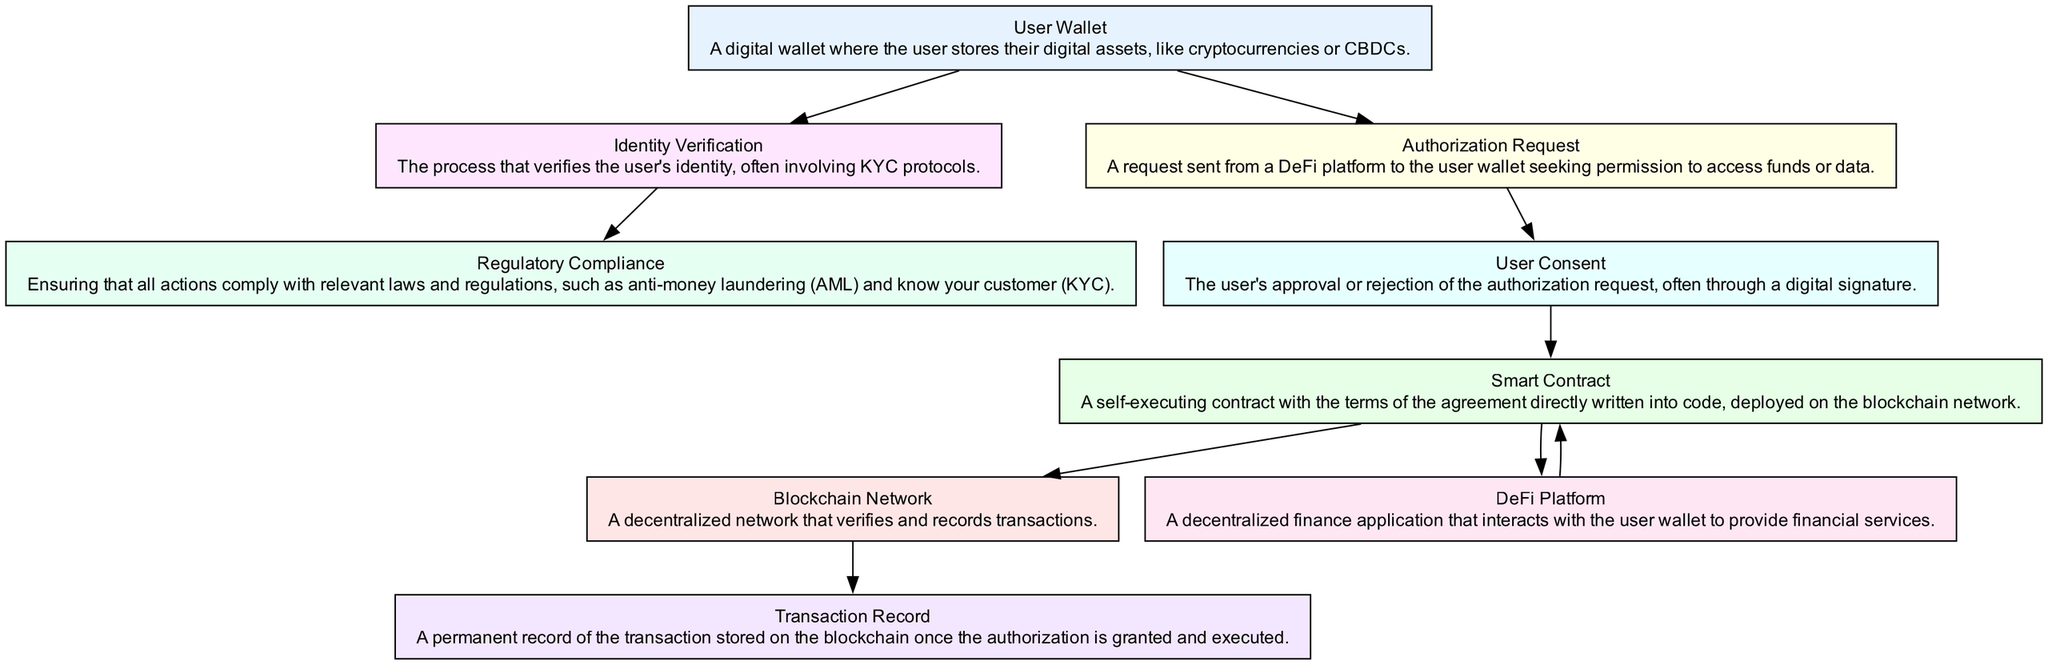What is the first step in the user authorization flow? The first step in the flow is represented by the 'User Wallet'. It is where the user begins the process before any authorization or verification occurs.
Answer: User Wallet How many nodes are present in the diagram? The diagram includes eight distinct nodes, each indicating a different aspect of the user authorization flow in DeFi.
Answer: Eight Which node is directly connected to both 'User Wallet' and 'Smart Contract'? The 'User Consent' node is the only one that connects directly from the 'User Wallet' through the authorization request to the 'Smart Contract'.
Answer: User Consent What is required after user identity verification? Following the completion of the 'Identity Verification', the process moves on to 'Regulatory Compliance', which ensures that the user's actions comply with necessary laws.
Answer: Regulatory Compliance What happens after 'User Consent' is given? The next action after 'User Consent' is the execution of the 'Smart Contract', which carries out the agreement based on the user's authorization.
Answer: Smart Contract Which two nodes are connected by an edge signifying interaction with the 'DeFi Platform'? The edge is directed between the 'Smart Contract' and 'DeFi Platform', indicating that the smart contract interacts with the platform to provide financial services.
Answer: DeFi Platform What is stored permanently after the authorization process is completed? A 'Transaction Record' is created and stored on the blockchain as a permanent record of the transaction that takes place following the user's consent and execution of the smart contract.
Answer: Transaction Record What type of contract is used in this flow? The flow utilizes a 'Smart Contract', which automates the execution of agreements on the blockchain network.
Answer: Smart Contract Which node follows the 'Authorization Request'? The 'User Consent' node directly follows the 'Authorization Request' as it represents the user's response to the request made by the DeFi platform.
Answer: User Consent 